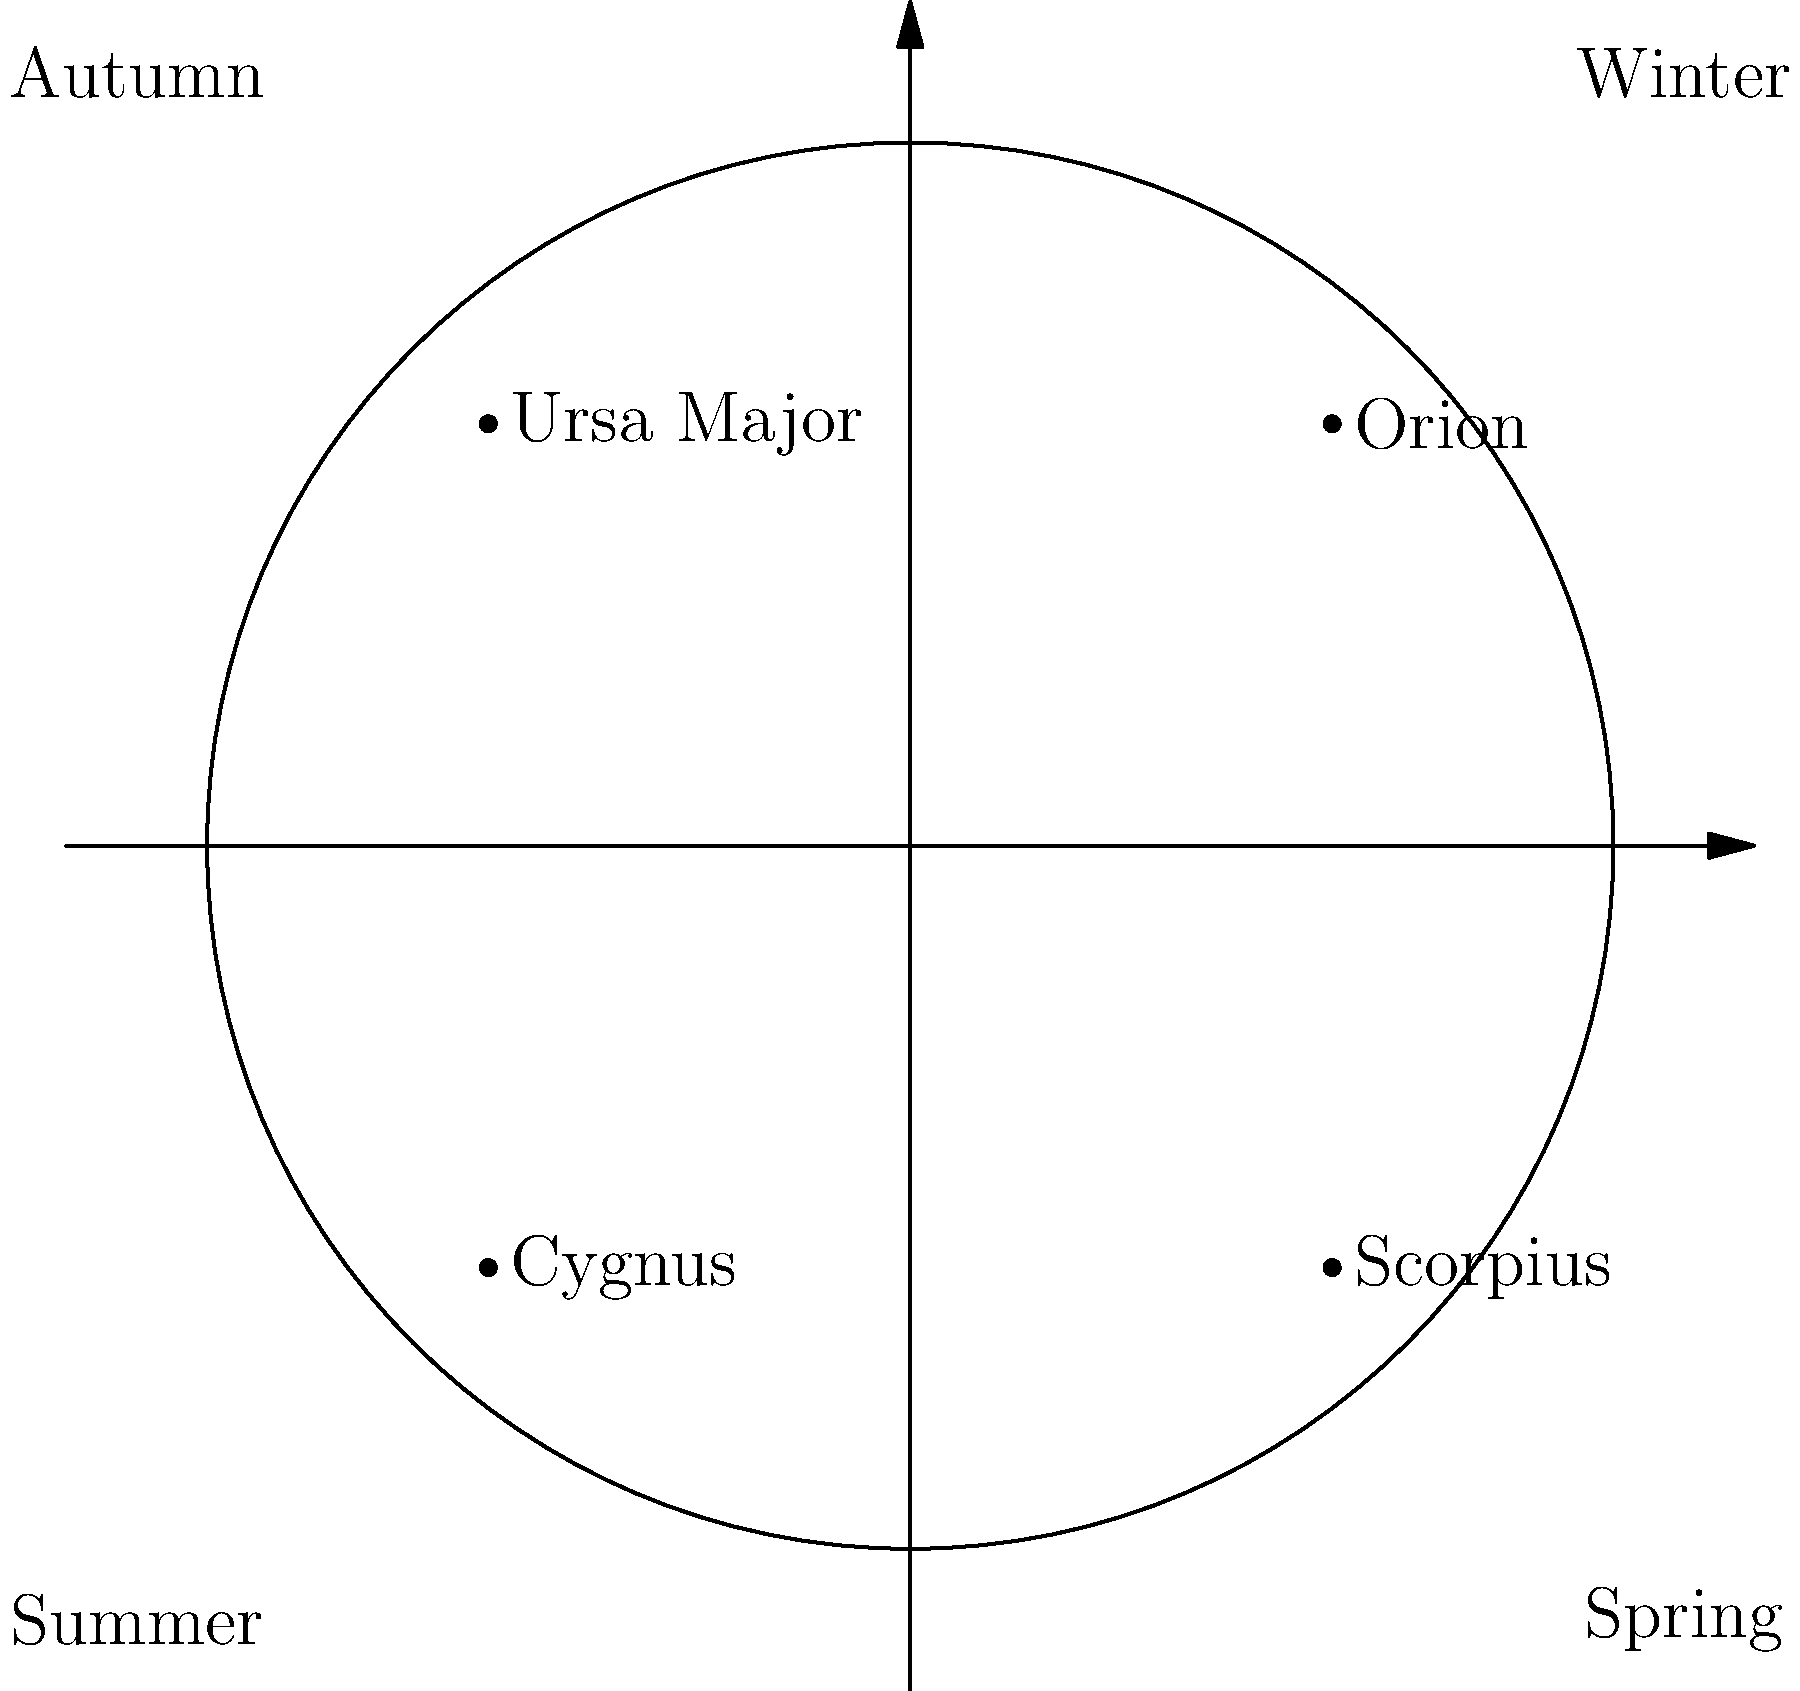As a convenience store owner who often chats with customers about the night sky, you've noticed that certain constellations are visible during specific seasons. Which constellation is most prominently visible during the winter months in the Northern Hemisphere? To understand why certain constellations are visible during specific seasons, we need to consider the Earth's orbit around the Sun and its axial tilt. Here's a step-by-step explanation:

1. Earth's orbit: The Earth orbits the Sun in an elliptical path, taking approximately 365.25 days to complete one revolution.

2. Earth's axial tilt: The Earth's axis is tilted at an angle of about 23.5 degrees relative to its orbital plane.

3. Seasonal changes: This tilt causes the seasons as different parts of Earth receive varying amounts of sunlight throughout the year.

4. Night sky visibility: As the Earth orbits the Sun, our view of the night sky changes because we're looking in different directions in space as the seasons progress.

5. Winter constellations: In the Northern Hemisphere winter (December to March), the night side of Earth faces towards the Orion arm of our galaxy.

6. Orion constellation: Orion is one of the most recognizable constellations and is prominently visible during winter nights in the Northern Hemisphere.

7. Other winter constellations: While Orion is the most prominent, other visible constellations include Taurus, Gemini, and Canis Major.

8. Summer contrast: In contrast, during summer months, Scorpius and Sagittarius are more visible as we face towards the center of the Milky Way galaxy.

Thus, Orion is the constellation most prominently visible during winter months in the Northern Hemisphere.
Answer: Orion 